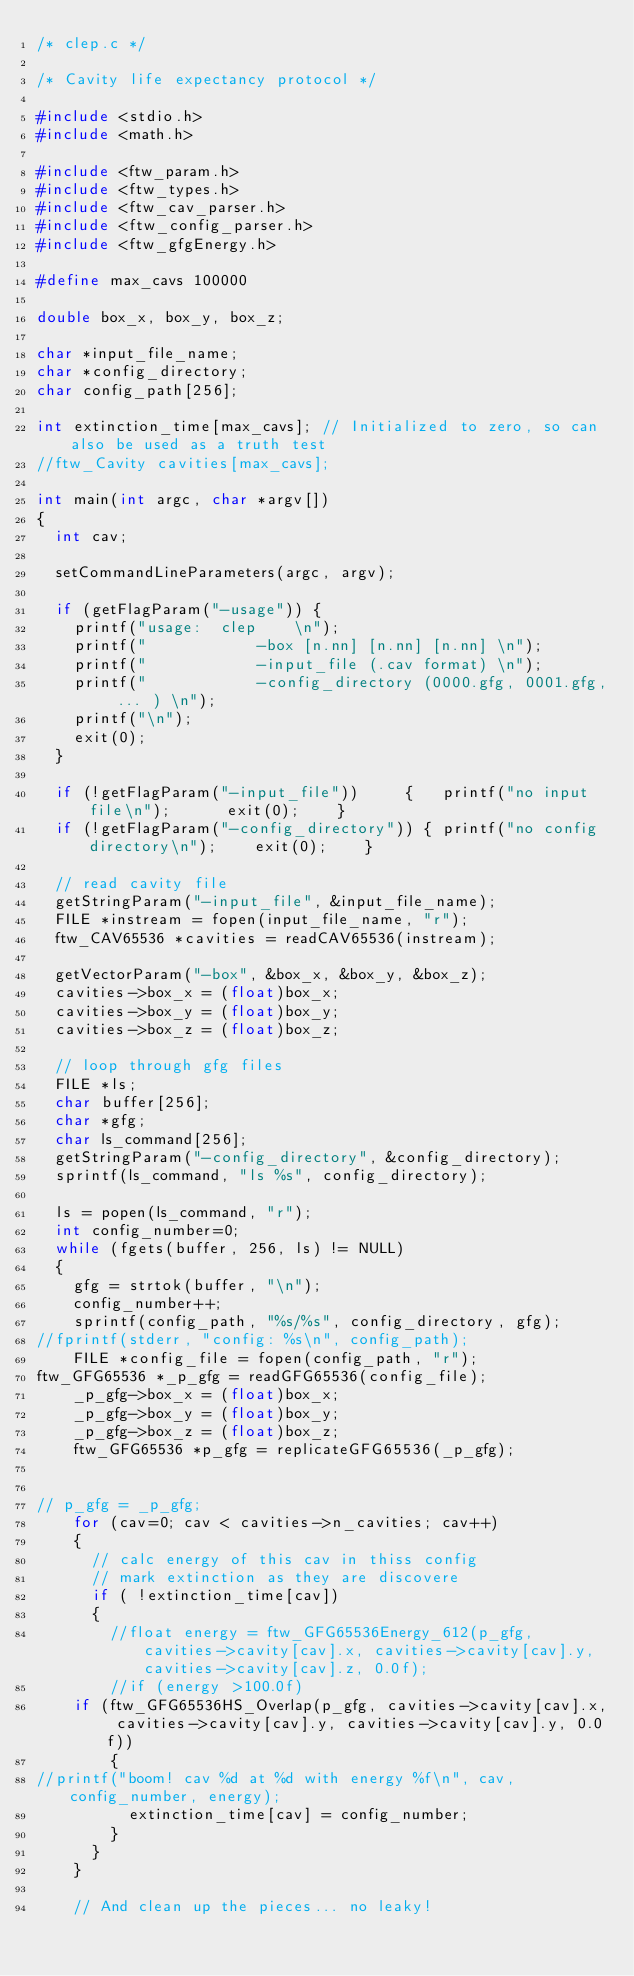<code> <loc_0><loc_0><loc_500><loc_500><_C_>/* clep.c */

/* Cavity life expectancy protocol */

#include <stdio.h>
#include <math.h>

#include <ftw_param.h>
#include <ftw_types.h>
#include <ftw_cav_parser.h>
#include <ftw_config_parser.h>
#include <ftw_gfgEnergy.h>

#define max_cavs 100000

double box_x, box_y, box_z;

char *input_file_name;
char *config_directory;
char config_path[256];

int extinction_time[max_cavs]; // Initialized to zero, so can also be used as a truth test
//ftw_Cavity cavities[max_cavs]; 

int main(int argc, char *argv[])
{
  int cav;

  setCommandLineParameters(argc, argv);

  if (getFlagParam("-usage")) {  
    printf("usage:	clep	\n");
    printf("			-box [n.nn] [n.nn] [n.nn] \n");
    printf("			-input_file (.cav format) \n");
    printf("			-config_directory (0000.gfg, 0001.gfg, ... ) \n");
    printf("\n");
    exit(0);
  }

  if (!getFlagParam("-input_file")) 	{	printf("no input file\n");		exit(0);	}
  if (!getFlagParam("-config_directory")) {	printf("no config directory\n");	exit(0);	}

  // read cavity file
  getStringParam("-input_file", &input_file_name);
  FILE *instream = fopen(input_file_name, "r");
  ftw_CAV65536 *cavities = readCAV65536(instream);

  getVectorParam("-box", &box_x, &box_y, &box_z);
  cavities->box_x = (float)box_x;
  cavities->box_y = (float)box_y;
  cavities->box_z = (float)box_z;

  // loop through gfg files
  FILE *ls;
  char buffer[256];
  char *gfg;
  char ls_command[256];
  getStringParam("-config_directory", &config_directory);
  sprintf(ls_command, "ls %s", config_directory);

  ls = popen(ls_command, "r"); 
  int config_number=0;
  while (fgets(buffer, 256, ls) != NULL)
  {
    gfg = strtok(buffer, "\n");
    config_number++;
    sprintf(config_path, "%s/%s", config_directory, gfg);
//fprintf(stderr, "config: %s\n", config_path);
    FILE *config_file = fopen(config_path, "r");
ftw_GFG65536 *_p_gfg = readGFG65536(config_file);
    _p_gfg->box_x = (float)box_x;
    _p_gfg->box_y = (float)box_y;
    _p_gfg->box_z = (float)box_z;
    ftw_GFG65536 *p_gfg = replicateGFG65536(_p_gfg);


// p_gfg = _p_gfg;
    for (cav=0; cav < cavities->n_cavities; cav++)
    {
      // calc energy of this cav in thiss config
      // mark extinction as they are discovere
      if ( !extinction_time[cav])
      {
        //float energy = ftw_GFG65536Energy_612(p_gfg, cavities->cavity[cav].x, cavities->cavity[cav].y, cavities->cavity[cav].z, 0.0f);
        //if (energy >100.0f) 
	if (ftw_GFG65536HS_Overlap(p_gfg, cavities->cavity[cav].x, cavities->cavity[cav].y, cavities->cavity[cav].y, 0.0f))
        {
//printf("boom! cav %d at %d with energy %f\n", cav, config_number, energy);
          extinction_time[cav] = config_number;
        }
      }
    } 

    // And clean up the pieces... no leaky!</code> 